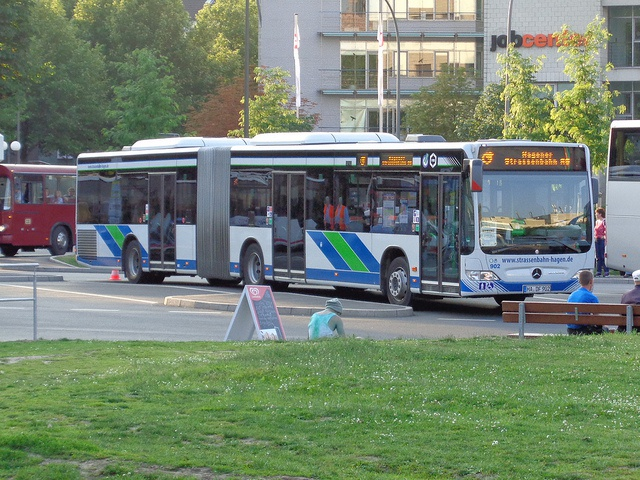Describe the objects in this image and their specific colors. I can see bus in darkgreen, gray, black, and white tones, bus in darkgreen, gray, brown, purple, and black tones, bus in darkgreen, darkgray, gray, and lightgray tones, bench in darkgreen, maroon, gray, and darkgray tones, and people in darkgreen, teal, darkgray, gray, and lightblue tones in this image. 